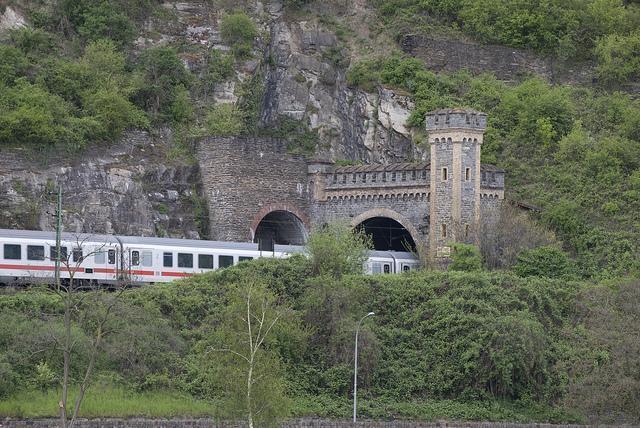How many cars of the train are visible?
Give a very brief answer. 3. 